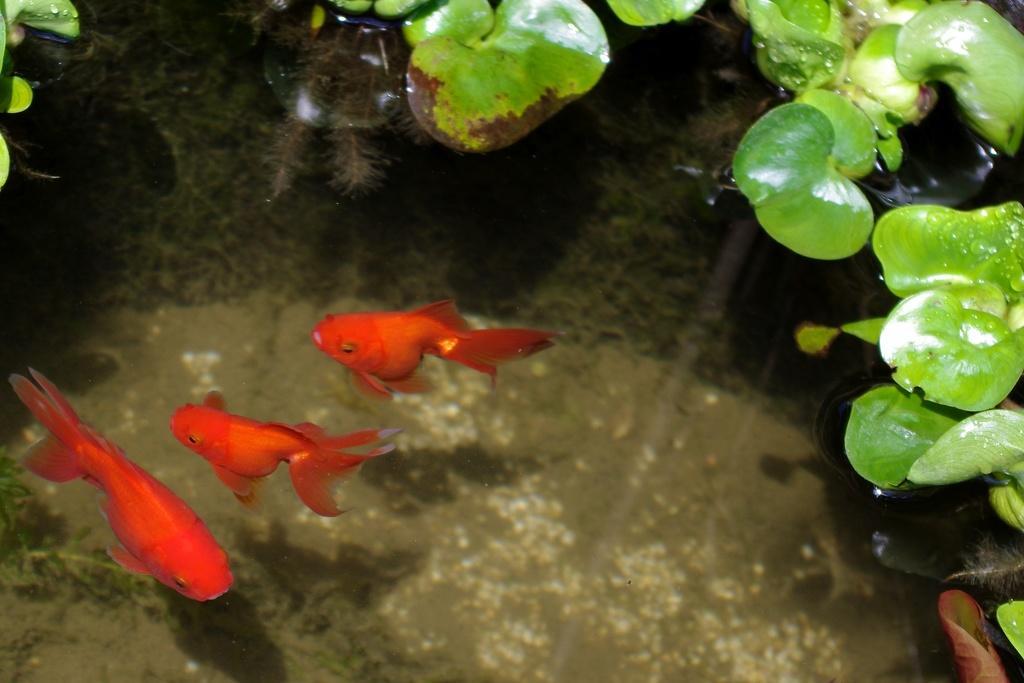Can you describe this image briefly? In this picture we can see three red color fish in the water. On the top right we can see green color leaves. 